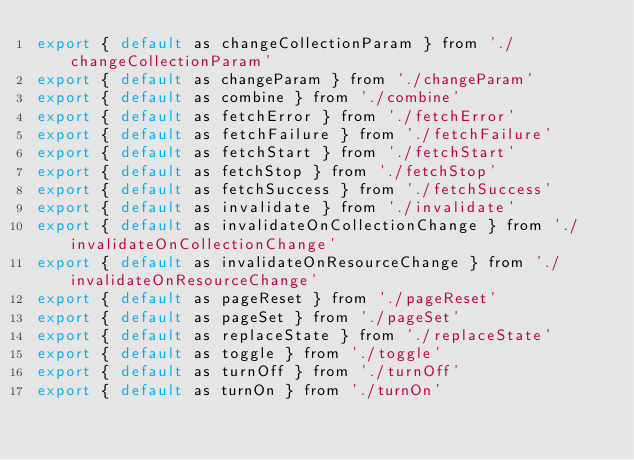<code> <loc_0><loc_0><loc_500><loc_500><_JavaScript_>export { default as changeCollectionParam } from './changeCollectionParam'
export { default as changeParam } from './changeParam'
export { default as combine } from './combine'
export { default as fetchError } from './fetchError'
export { default as fetchFailure } from './fetchFailure'
export { default as fetchStart } from './fetchStart'
export { default as fetchStop } from './fetchStop'
export { default as fetchSuccess } from './fetchSuccess'
export { default as invalidate } from './invalidate'
export { default as invalidateOnCollectionChange } from './invalidateOnCollectionChange'
export { default as invalidateOnResourceChange } from './invalidateOnResourceChange'
export { default as pageReset } from './pageReset'
export { default as pageSet } from './pageSet'
export { default as replaceState } from './replaceState'
export { default as toggle } from './toggle'
export { default as turnOff } from './turnOff'
export { default as turnOn } from './turnOn'
</code> 